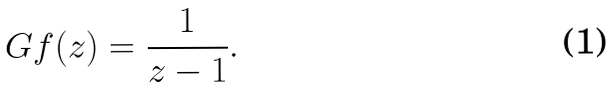<formula> <loc_0><loc_0><loc_500><loc_500>\ G f ( z ) = \frac { 1 } { z - 1 } .</formula> 